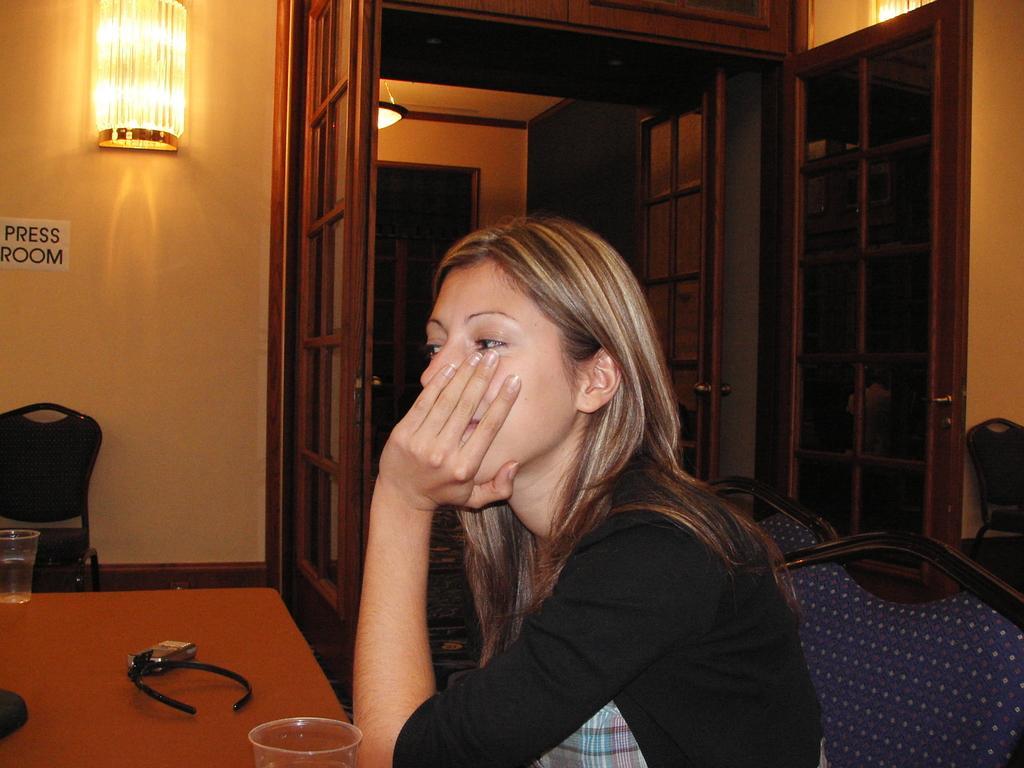How would you summarize this image in a sentence or two? A woman is sitting on a chair. In front of her there is a table. On the table there is hair band, box and a glass. In the background there is a door, wall, light, chair and paper on the wall. Also a cupboard. 